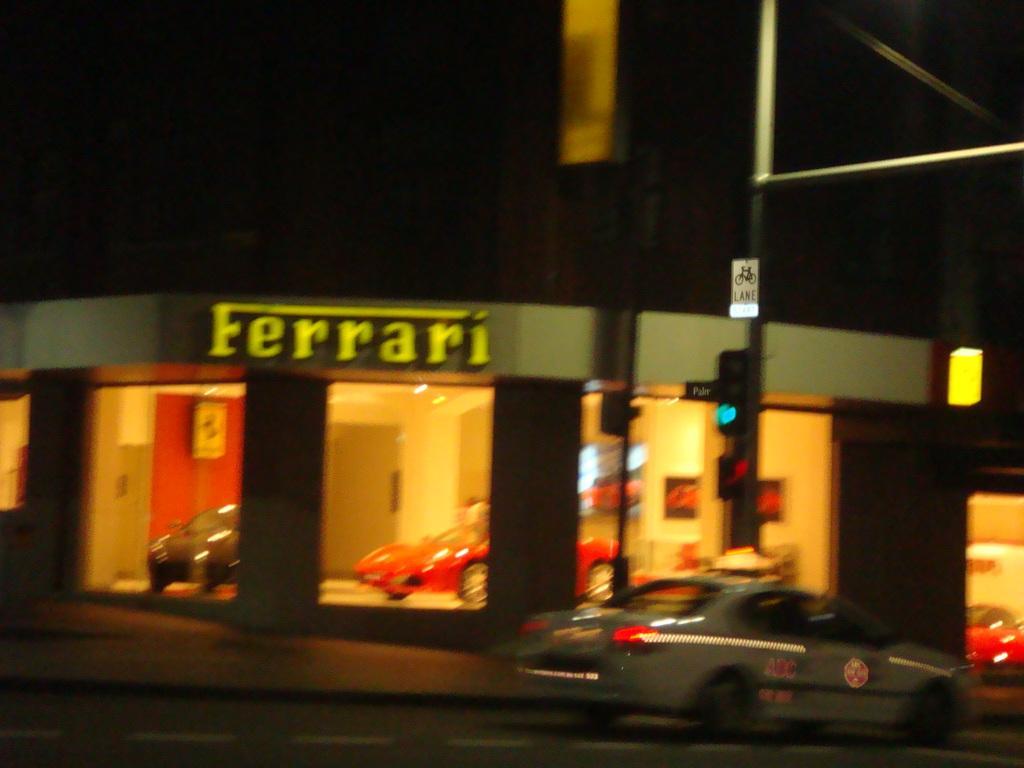Could you give a brief overview of what you see in this image? The image is blurred. In the foreground of the picture there is a car on the road. In the center of the picture there are poles, board, signal light and cables. In the background there is a car showroom, in the showroom there are cars. At the top it is dark. 